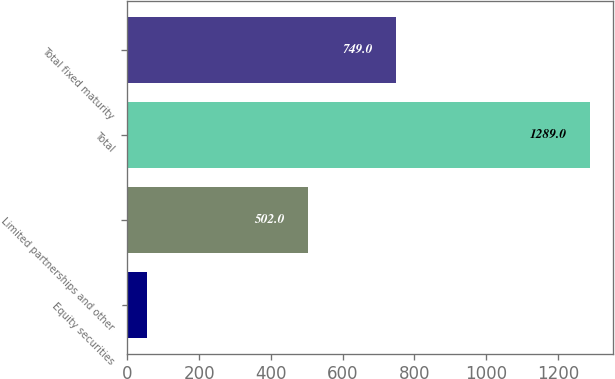<chart> <loc_0><loc_0><loc_500><loc_500><bar_chart><fcel>Equity securities<fcel>Limited partnerships and other<fcel>Total<fcel>Total fixed maturity<nl><fcel>54<fcel>502<fcel>1289<fcel>749<nl></chart> 